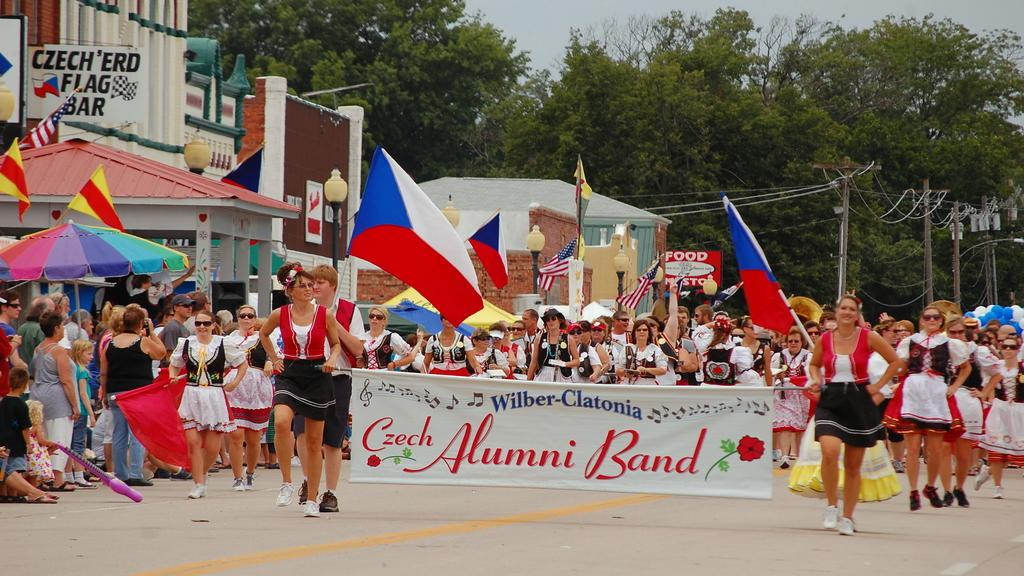What are the people in the image doing? The people in the image are walking on the road and holding flags and banners. Are there any spectators in the image? Yes, there are people standing and watching in the image. How many dimes can be seen on the ground in the image? There are no dimes visible on the ground in the image. In which direction are the people walking in the image? The direction in which the people are walking cannot be determined from the image. 